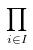<formula> <loc_0><loc_0><loc_500><loc_500>\prod _ { i \in I }</formula> 